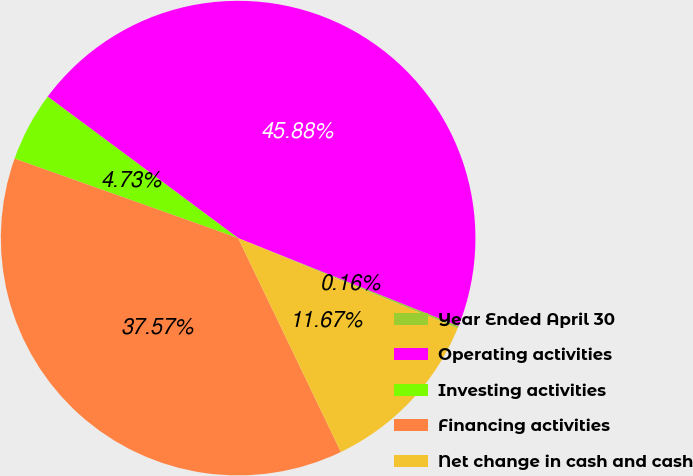<chart> <loc_0><loc_0><loc_500><loc_500><pie_chart><fcel>Year Ended April 30<fcel>Operating activities<fcel>Investing activities<fcel>Financing activities<fcel>Net change in cash and cash<nl><fcel>0.16%<fcel>45.88%<fcel>4.73%<fcel>37.57%<fcel>11.67%<nl></chart> 